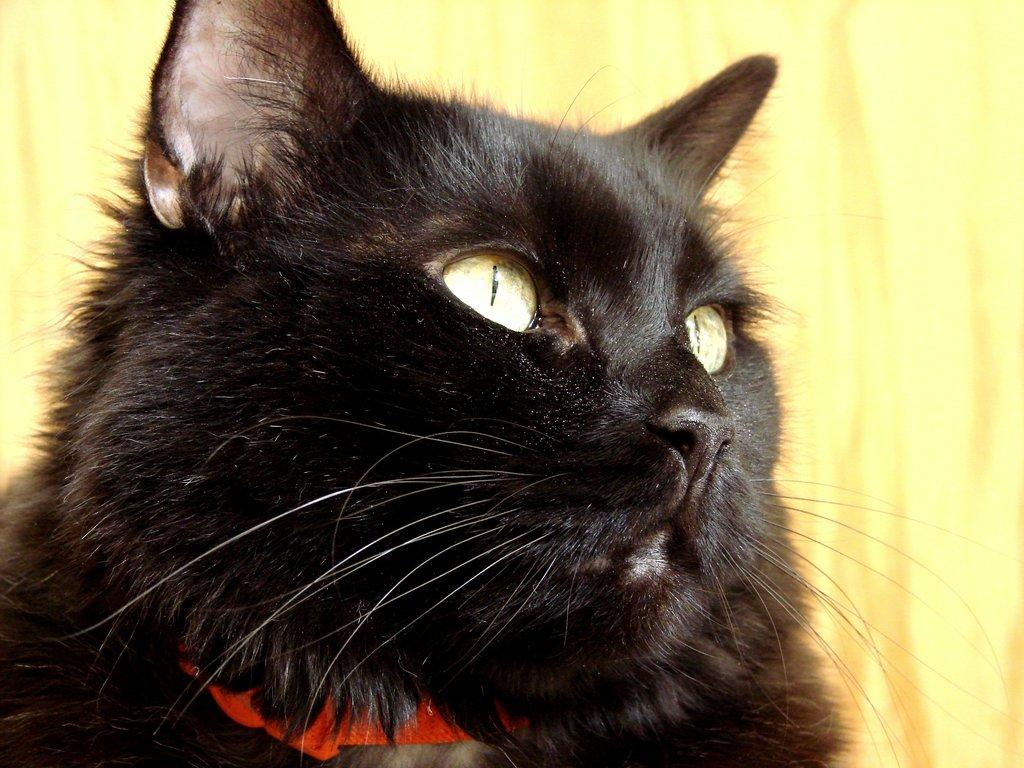What type of animal is in the image? There is a cat in the image. What can be seen in the background of the image? There is a curtain in the background of the image. What event is the cat attending in the image? There is no event depicted in the image; it simply shows a cat and a curtain in the background. What is the cat learning in the image? There is no indication of the cat learning anything in the image. 